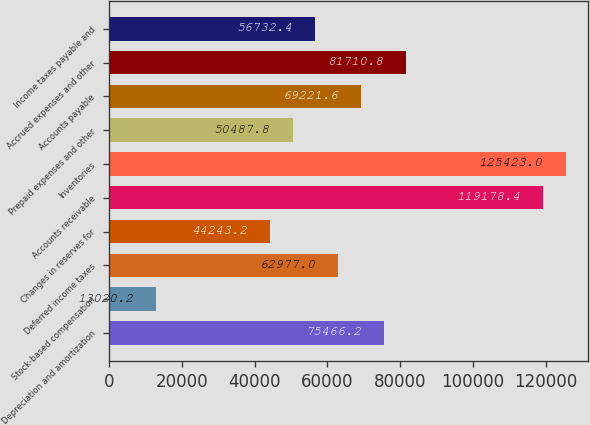Convert chart to OTSL. <chart><loc_0><loc_0><loc_500><loc_500><bar_chart><fcel>Depreciation and amortization<fcel>Stock-based compensation<fcel>Deferred income taxes<fcel>Changes in reserves for<fcel>Accounts receivable<fcel>Inventories<fcel>Prepaid expenses and other<fcel>Accounts payable<fcel>Accrued expenses and other<fcel>Income taxes payable and<nl><fcel>75466.2<fcel>13020.2<fcel>62977<fcel>44243.2<fcel>119178<fcel>125423<fcel>50487.8<fcel>69221.6<fcel>81710.8<fcel>56732.4<nl></chart> 